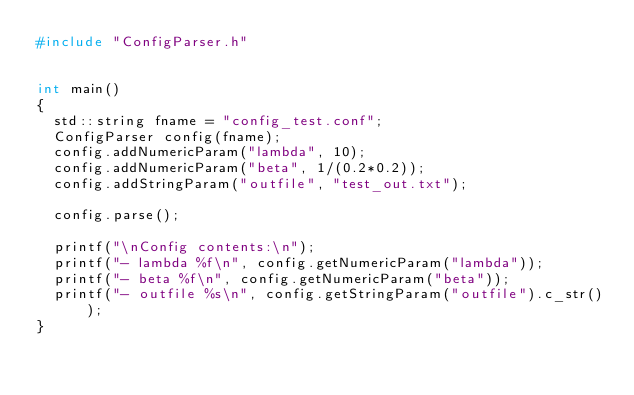Convert code to text. <code><loc_0><loc_0><loc_500><loc_500><_C++_>#include "ConfigParser.h"


int main()
{
  std::string fname = "config_test.conf";
  ConfigParser config(fname);
  config.addNumericParam("lambda", 10);
  config.addNumericParam("beta", 1/(0.2*0.2));
  config.addStringParam("outfile", "test_out.txt");

  config.parse();

  printf("\nConfig contents:\n");
  printf("- lambda %f\n", config.getNumericParam("lambda"));
  printf("- beta %f\n", config.getNumericParam("beta"));
  printf("- outfile %s\n", config.getStringParam("outfile").c_str());
}
</code> 